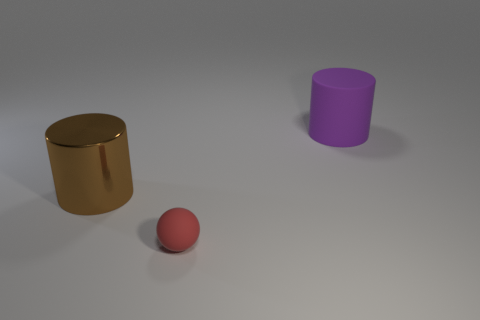Add 1 small objects. How many objects exist? 4 Subtract all balls. How many objects are left? 2 Subtract all large green rubber objects. Subtract all cylinders. How many objects are left? 1 Add 2 brown metal cylinders. How many brown metal cylinders are left? 3 Add 1 small red things. How many small red things exist? 2 Subtract 0 brown balls. How many objects are left? 3 